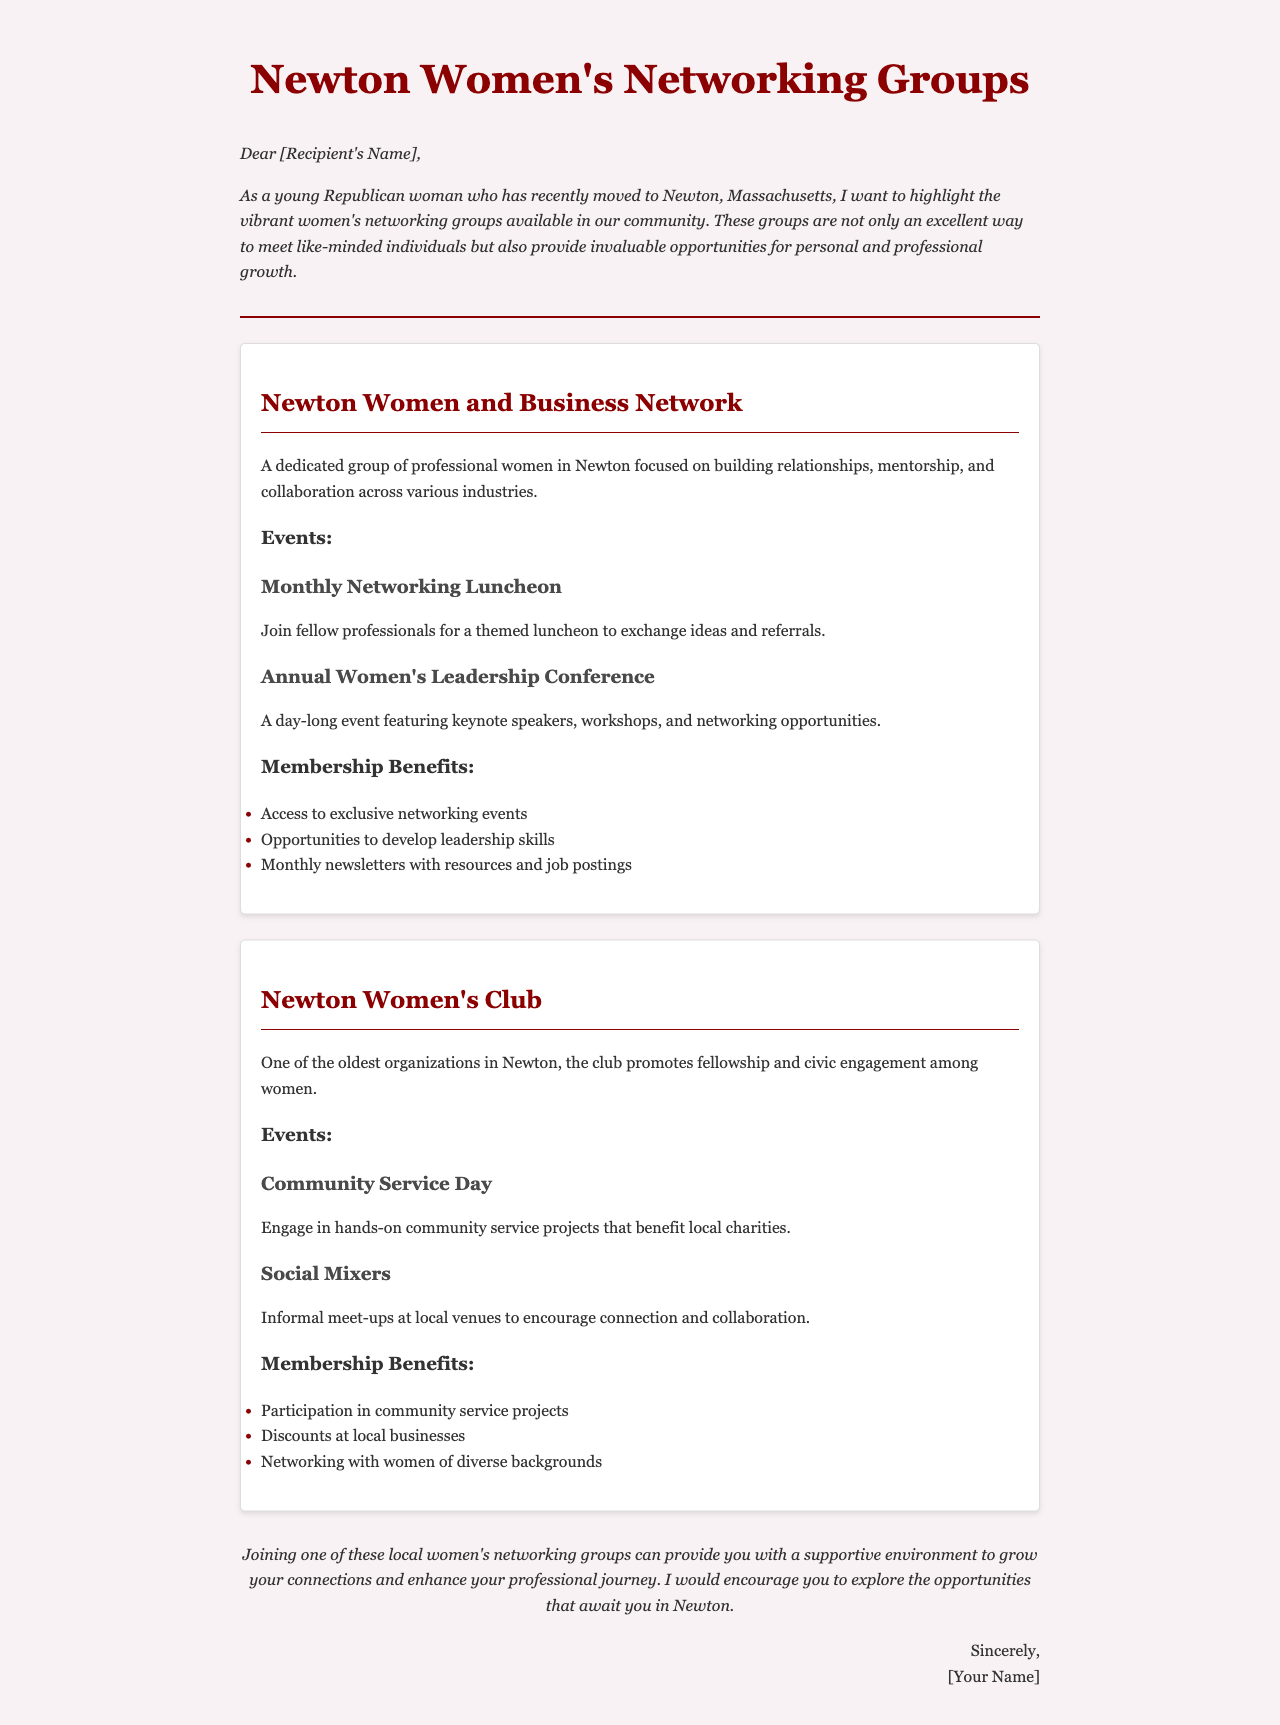What is the title of the document? The title of the document is stated in the <title> tag within the HTML, which introduces the subject matter.
Answer: Newton Women's Networking Groups What is one event hosted by the Newton Women and Business Network? The document lists specific events related to each group, highlighting their exclusivity and purpose.
Answer: Monthly Networking Luncheon What is a benefit of joining the Newton Women's Club? The membership benefits are clearly outlined for both groups, emphasizing the perks of joining.
Answer: Discounts at local businesses How often does the Newton Women and Business Network host events? The frequency of events is indicated through examples of the types of events scheduled in the document.
Answer: Monthly What is the purpose of the Community Service Day event? The purpose of the event is described, showing how it links to civic engagement and community support.
Answer: Engage in hands-on community service projects What type of professionals does the Newton Women and Business Network cater to? The document describes the intended audience for the networking group, focusing on their professional backgrounds.
Answer: Professional women What style is used in the introduction of the document? The introduction uses a specific stylistic choice that adds atmosphere to the letter's opening.
Answer: Italic How does the letter sign off? The closing of the letter follows a common format used in personal correspondence, indicating the sender's intentions.
Answer: Sincerely 